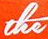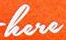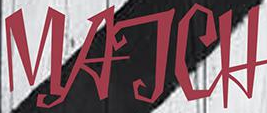What words can you see in these images in sequence, separated by a semicolon? the; here; MATCH 